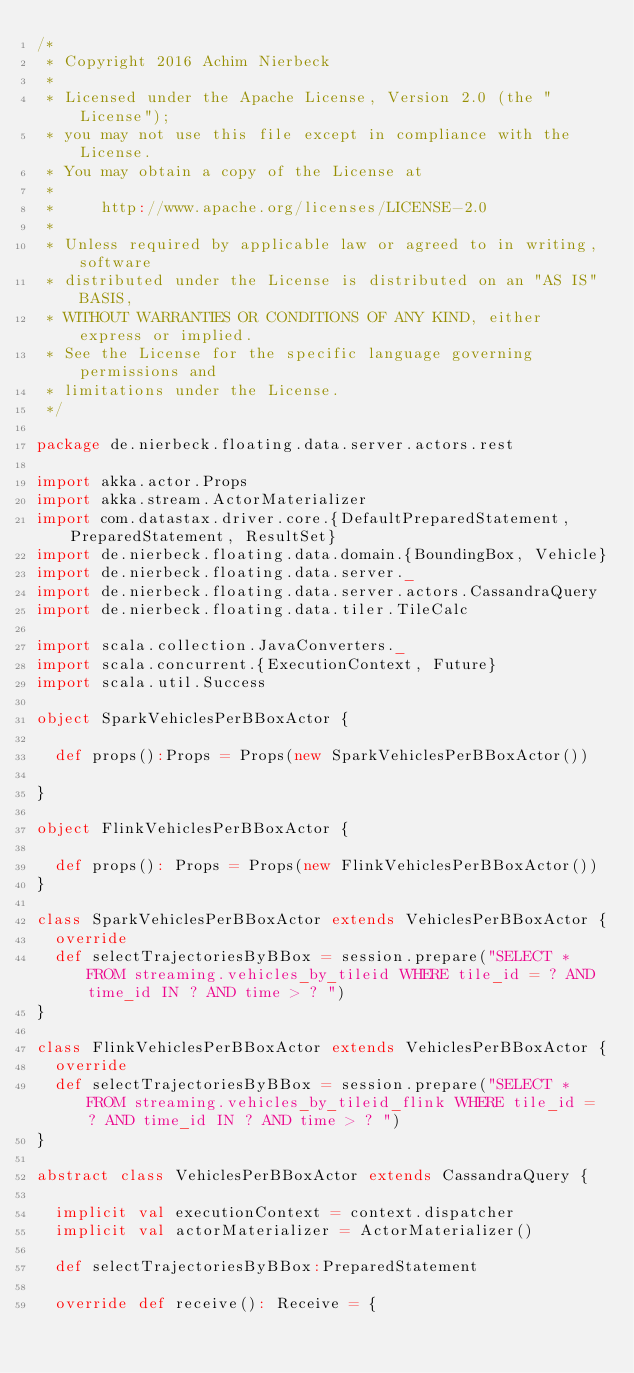Convert code to text. <code><loc_0><loc_0><loc_500><loc_500><_Scala_>/*
 * Copyright 2016 Achim Nierbeck
 *
 * Licensed under the Apache License, Version 2.0 (the "License");
 * you may not use this file except in compliance with the License.
 * You may obtain a copy of the License at
 *
 *     http://www.apache.org/licenses/LICENSE-2.0
 *
 * Unless required by applicable law or agreed to in writing, software
 * distributed under the License is distributed on an "AS IS" BASIS,
 * WITHOUT WARRANTIES OR CONDITIONS OF ANY KIND, either express or implied.
 * See the License for the specific language governing permissions and
 * limitations under the License.
 */

package de.nierbeck.floating.data.server.actors.rest

import akka.actor.Props
import akka.stream.ActorMaterializer
import com.datastax.driver.core.{DefaultPreparedStatement, PreparedStatement, ResultSet}
import de.nierbeck.floating.data.domain.{BoundingBox, Vehicle}
import de.nierbeck.floating.data.server._
import de.nierbeck.floating.data.server.actors.CassandraQuery
import de.nierbeck.floating.data.tiler.TileCalc

import scala.collection.JavaConverters._
import scala.concurrent.{ExecutionContext, Future}
import scala.util.Success

object SparkVehiclesPerBBoxActor {

  def props():Props = Props(new SparkVehiclesPerBBoxActor())

}

object FlinkVehiclesPerBBoxActor {

  def props(): Props = Props(new FlinkVehiclesPerBBoxActor())
}

class SparkVehiclesPerBBoxActor extends VehiclesPerBBoxActor {
  override
  def selectTrajectoriesByBBox = session.prepare("SELECT * FROM streaming.vehicles_by_tileid WHERE tile_id = ? AND time_id IN ? AND time > ? ")
}

class FlinkVehiclesPerBBoxActor extends VehiclesPerBBoxActor {
  override
  def selectTrajectoriesByBBox = session.prepare("SELECT * FROM streaming.vehicles_by_tileid_flink WHERE tile_id = ? AND time_id IN ? AND time > ? ")
}

abstract class VehiclesPerBBoxActor extends CassandraQuery {

  implicit val executionContext = context.dispatcher
  implicit val actorMaterializer = ActorMaterializer()

  def selectTrajectoriesByBBox:PreparedStatement

  override def receive(): Receive = {</code> 